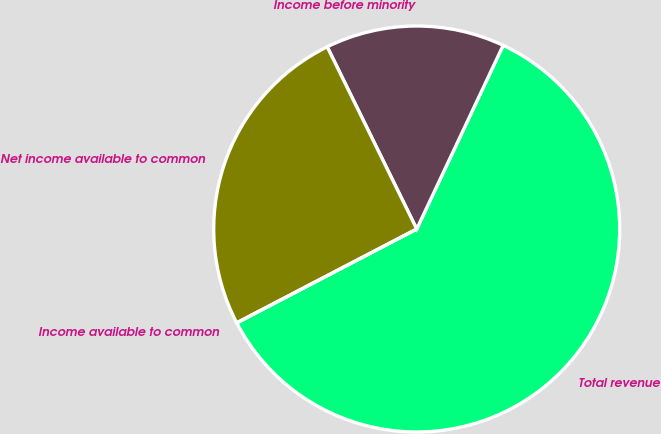Convert chart. <chart><loc_0><loc_0><loc_500><loc_500><pie_chart><fcel>Total revenue<fcel>Income before minority<fcel>Net income available to common<fcel>Income available to common<nl><fcel>60.35%<fcel>14.27%<fcel>25.38%<fcel>0.0%<nl></chart> 